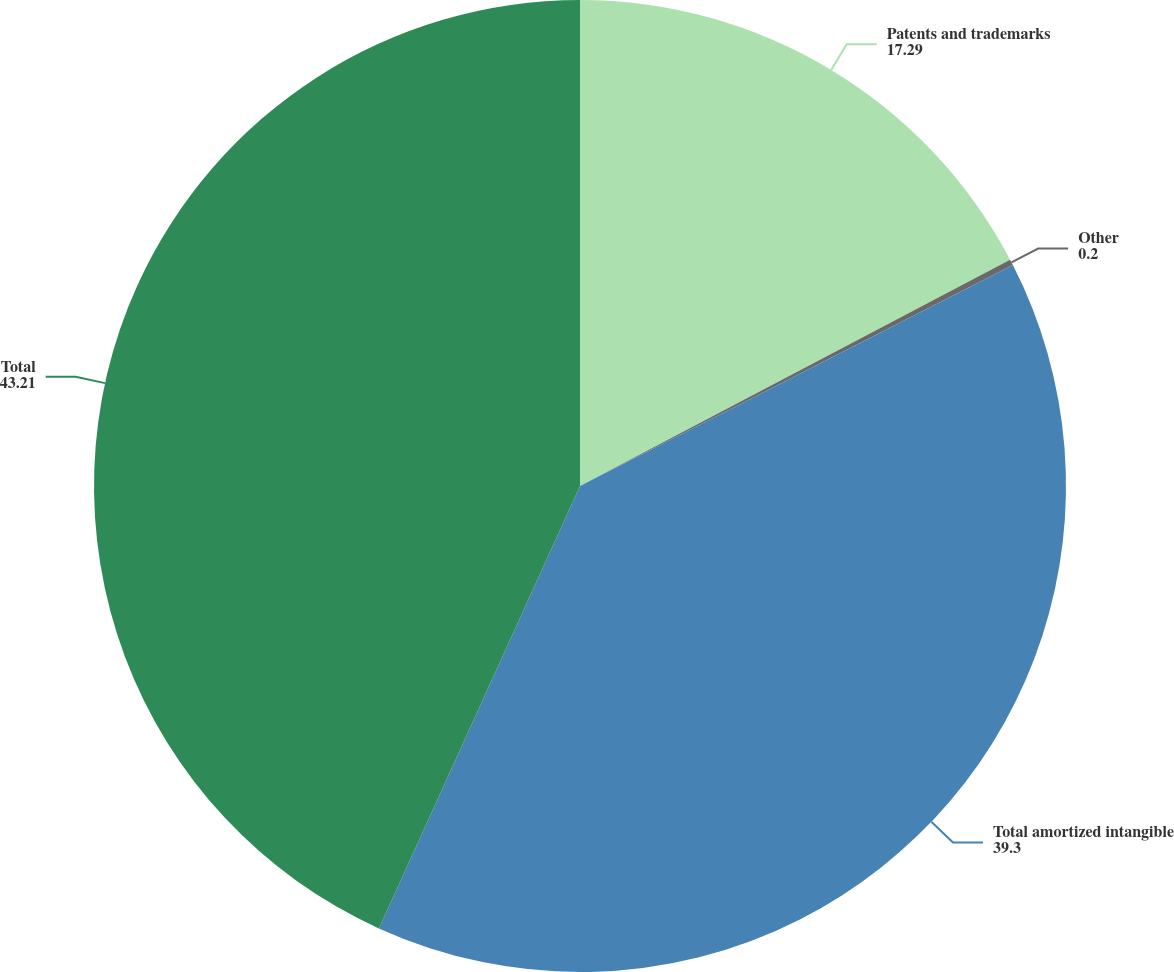Convert chart. <chart><loc_0><loc_0><loc_500><loc_500><pie_chart><fcel>Patents and trademarks<fcel>Other<fcel>Total amortized intangible<fcel>Total<nl><fcel>17.29%<fcel>0.2%<fcel>39.3%<fcel>43.21%<nl></chart> 